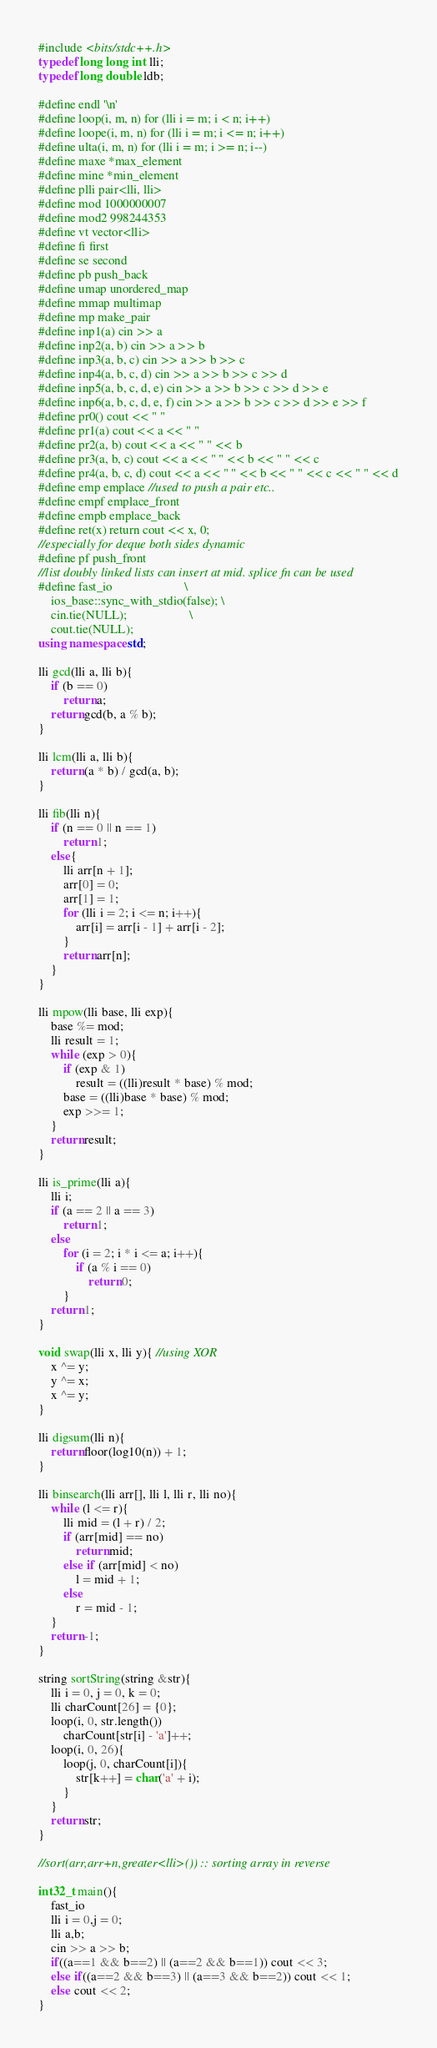<code> <loc_0><loc_0><loc_500><loc_500><_C++_>#include <bits/stdc++.h>
typedef long long int lli;
typedef long double ldb;
 
#define endl '\n'
#define loop(i, m, n) for (lli i = m; i < n; i++)
#define loope(i, m, n) for (lli i = m; i <= n; i++)
#define ulta(i, m, n) for (lli i = m; i >= n; i--)
#define maxe *max_element
#define mine *min_element
#define plli pair<lli, lli>
#define mod 1000000007
#define mod2 998244353
#define vt vector<lli>
#define fi first
#define se second
#define pb push_back
#define umap unordered_map
#define mmap multimap
#define mp make_pair
#define inp1(a) cin >> a
#define inp2(a, b) cin >> a >> b
#define inp3(a, b, c) cin >> a >> b >> c
#define inp4(a, b, c, d) cin >> a >> b >> c >> d
#define inp5(a, b, c, d, e) cin >> a >> b >> c >> d >> e
#define inp6(a, b, c, d, e, f) cin >> a >> b >> c >> d >> e >> f
#define pr0() cout << " "
#define pr1(a) cout << a << " "
#define pr2(a, b) cout << a << " " << b
#define pr3(a, b, c) cout << a << " " << b << " " << c
#define pr4(a, b, c, d) cout << a << " " << b << " " << c << " " << d
#define emp emplace //used to push a pair etc..
#define empf emplace_front
#define empb emplace_back
#define ret(x) return cout << x, 0;
//especially for deque both sides dynamic
#define pf push_front
//list doubly linked lists can insert at mid. splice fn can be used
#define fast_io                       \
    ios_base::sync_with_stdio(false); \
    cin.tie(NULL);                    \
    cout.tie(NULL);
using namespace std;
 
lli gcd(lli a, lli b){
    if (b == 0)
        return a;
    return gcd(b, a % b);
}
 
lli lcm(lli a, lli b){
    return (a * b) / gcd(a, b);
}
 
lli fib(lli n){
    if (n == 0 || n == 1)
        return 1;
    else{
        lli arr[n + 1];
        arr[0] = 0;
        arr[1] = 1;
        for (lli i = 2; i <= n; i++){
            arr[i] = arr[i - 1] + arr[i - 2];
        }
        return arr[n];
    }
}
 
lli mpow(lli base, lli exp){
    base %= mod;
    lli result = 1;
    while (exp > 0){
        if (exp & 1)
            result = ((lli)result * base) % mod;
        base = ((lli)base * base) % mod;
        exp >>= 1;
    }
    return result;
}
 
lli is_prime(lli a){
    lli i;
    if (a == 2 || a == 3)
        return 1;
    else
        for (i = 2; i * i <= a; i++){
            if (a % i == 0)
                return 0;
        }
    return 1;
}
 
void swap(lli x, lli y){ //using XOR
    x ^= y;
    y ^= x;
    x ^= y;
}
 
lli digsum(lli n){
    return floor(log10(n)) + 1;
}
 
lli binsearch(lli arr[], lli l, lli r, lli no){
    while (l <= r){
        lli mid = (l + r) / 2;
        if (arr[mid] == no)
            return mid;
        else if (arr[mid] < no)
            l = mid + 1;
        else
            r = mid - 1;
    }
    return -1;
}
 
string sortString(string &str){
    lli i = 0, j = 0, k = 0;
    lli charCount[26] = {0};
    loop(i, 0, str.length())
        charCount[str[i] - 'a']++;
    loop(i, 0, 26){
        loop(j, 0, charCount[i]){
            str[k++] = char('a' + i);
        }
    }
    return str;
}

//sort(arr,arr+n,greater<lli>()) :: sorting array in reverse
 
int32_t main(){
    fast_io
    lli i = 0,j = 0;
    lli a,b;
    cin >> a >> b;
    if((a==1 && b==2) || (a==2 && b==1)) cout << 3;
    else if((a==2 && b==3) || (a==3 && b==2)) cout << 1;
    else cout << 2;
}</code> 